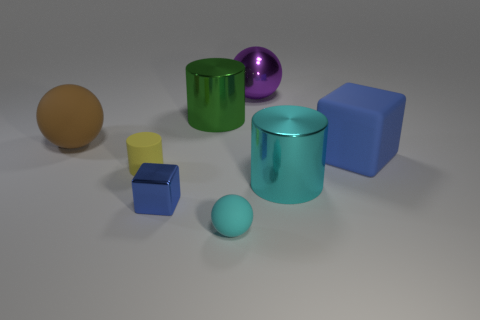Subtract all large purple balls. How many balls are left? 2 Add 1 yellow rubber objects. How many objects exist? 9 Subtract all purple spheres. How many spheres are left? 2 Subtract all cylinders. How many objects are left? 5 Subtract all gray cylinders. How many brown balls are left? 1 Add 3 small yellow shiny spheres. How many small yellow shiny spheres exist? 3 Subtract 0 red cylinders. How many objects are left? 8 Subtract all blue cylinders. Subtract all yellow balls. How many cylinders are left? 3 Subtract all big metal cylinders. Subtract all small cyan spheres. How many objects are left? 5 Add 6 tiny cyan matte balls. How many tiny cyan matte balls are left? 7 